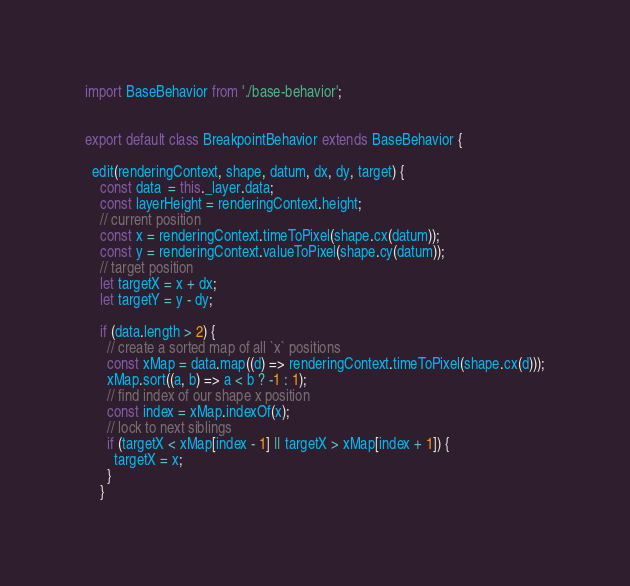Convert code to text. <code><loc_0><loc_0><loc_500><loc_500><_JavaScript_>import BaseBehavior from './base-behavior';


export default class BreakpointBehavior extends BaseBehavior {

  edit(renderingContext, shape, datum, dx, dy, target) {
    const data  = this._layer.data;
    const layerHeight = renderingContext.height;
    // current position
    const x = renderingContext.timeToPixel(shape.cx(datum));
    const y = renderingContext.valueToPixel(shape.cy(datum));
    // target position
    let targetX = x + dx;
    let targetY = y - dy;

    if (data.length > 2) {
      // create a sorted map of all `x` positions
      const xMap = data.map((d) => renderingContext.timeToPixel(shape.cx(d)));
      xMap.sort((a, b) => a < b ? -1 : 1);
      // find index of our shape x position
      const index = xMap.indexOf(x);
      // lock to next siblings
      if (targetX < xMap[index - 1] || targetX > xMap[index + 1]) {
        targetX = x;
      }
    }
</code> 